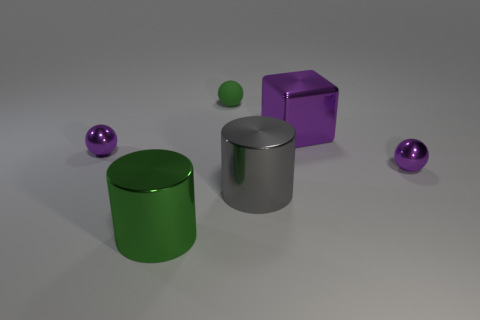Subtract all metal spheres. How many spheres are left? 1 Subtract all green spheres. How many spheres are left? 2 Subtract 1 spheres. How many spheres are left? 2 Add 1 objects. How many objects exist? 7 Subtract 0 brown cylinders. How many objects are left? 6 Subtract all cylinders. How many objects are left? 4 Subtract all blue cylinders. Subtract all cyan spheres. How many cylinders are left? 2 Subtract all red cylinders. How many green balls are left? 1 Subtract all rubber balls. Subtract all metal blocks. How many objects are left? 4 Add 3 small green rubber objects. How many small green rubber objects are left? 4 